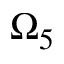Convert formula to latex. <formula><loc_0><loc_0><loc_500><loc_500>\Omega _ { 5 }</formula> 